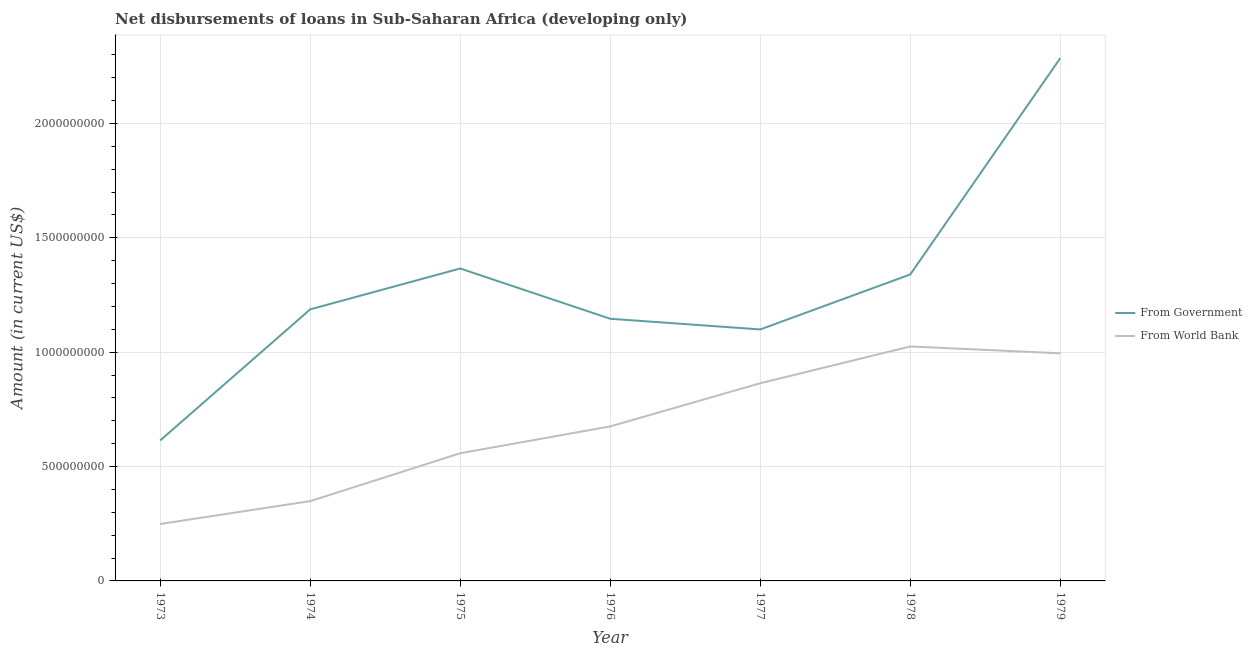Does the line corresponding to net disbursements of loan from government intersect with the line corresponding to net disbursements of loan from world bank?
Give a very brief answer. No. Is the number of lines equal to the number of legend labels?
Provide a succinct answer. Yes. What is the net disbursements of loan from world bank in 1979?
Keep it short and to the point. 9.95e+08. Across all years, what is the maximum net disbursements of loan from world bank?
Your response must be concise. 1.02e+09. Across all years, what is the minimum net disbursements of loan from world bank?
Provide a succinct answer. 2.49e+08. In which year was the net disbursements of loan from world bank maximum?
Offer a terse response. 1978. In which year was the net disbursements of loan from world bank minimum?
Your answer should be very brief. 1973. What is the total net disbursements of loan from world bank in the graph?
Offer a terse response. 4.72e+09. What is the difference between the net disbursements of loan from world bank in 1974 and that in 1978?
Provide a short and direct response. -6.76e+08. What is the difference between the net disbursements of loan from world bank in 1977 and the net disbursements of loan from government in 1973?
Offer a very short reply. 2.50e+08. What is the average net disbursements of loan from world bank per year?
Make the answer very short. 6.74e+08. In the year 1979, what is the difference between the net disbursements of loan from government and net disbursements of loan from world bank?
Offer a terse response. 1.29e+09. What is the ratio of the net disbursements of loan from government in 1975 to that in 1978?
Your answer should be very brief. 1.02. Is the net disbursements of loan from world bank in 1975 less than that in 1977?
Provide a short and direct response. Yes. Is the difference between the net disbursements of loan from government in 1973 and 1975 greater than the difference between the net disbursements of loan from world bank in 1973 and 1975?
Make the answer very short. No. What is the difference between the highest and the second highest net disbursements of loan from world bank?
Ensure brevity in your answer.  3.00e+07. What is the difference between the highest and the lowest net disbursements of loan from world bank?
Make the answer very short. 7.76e+08. Is the net disbursements of loan from world bank strictly greater than the net disbursements of loan from government over the years?
Give a very brief answer. No. Is the net disbursements of loan from world bank strictly less than the net disbursements of loan from government over the years?
Your answer should be compact. Yes. How many lines are there?
Your response must be concise. 2. How many years are there in the graph?
Provide a succinct answer. 7. What is the difference between two consecutive major ticks on the Y-axis?
Your answer should be compact. 5.00e+08. Where does the legend appear in the graph?
Offer a terse response. Center right. How many legend labels are there?
Your answer should be compact. 2. How are the legend labels stacked?
Provide a succinct answer. Vertical. What is the title of the graph?
Give a very brief answer. Net disbursements of loans in Sub-Saharan Africa (developing only). Does "Foreign liabilities" appear as one of the legend labels in the graph?
Provide a short and direct response. No. What is the Amount (in current US$) in From Government in 1973?
Offer a very short reply. 6.14e+08. What is the Amount (in current US$) of From World Bank in 1973?
Your answer should be compact. 2.49e+08. What is the Amount (in current US$) of From Government in 1974?
Provide a short and direct response. 1.19e+09. What is the Amount (in current US$) in From World Bank in 1974?
Your response must be concise. 3.49e+08. What is the Amount (in current US$) of From Government in 1975?
Your answer should be very brief. 1.37e+09. What is the Amount (in current US$) in From World Bank in 1975?
Your response must be concise. 5.58e+08. What is the Amount (in current US$) in From Government in 1976?
Provide a short and direct response. 1.15e+09. What is the Amount (in current US$) of From World Bank in 1976?
Keep it short and to the point. 6.75e+08. What is the Amount (in current US$) in From Government in 1977?
Ensure brevity in your answer.  1.10e+09. What is the Amount (in current US$) of From World Bank in 1977?
Make the answer very short. 8.64e+08. What is the Amount (in current US$) in From Government in 1978?
Offer a terse response. 1.34e+09. What is the Amount (in current US$) in From World Bank in 1978?
Make the answer very short. 1.02e+09. What is the Amount (in current US$) of From Government in 1979?
Give a very brief answer. 2.29e+09. What is the Amount (in current US$) in From World Bank in 1979?
Make the answer very short. 9.95e+08. Across all years, what is the maximum Amount (in current US$) in From Government?
Offer a terse response. 2.29e+09. Across all years, what is the maximum Amount (in current US$) of From World Bank?
Give a very brief answer. 1.02e+09. Across all years, what is the minimum Amount (in current US$) of From Government?
Give a very brief answer. 6.14e+08. Across all years, what is the minimum Amount (in current US$) in From World Bank?
Keep it short and to the point. 2.49e+08. What is the total Amount (in current US$) in From Government in the graph?
Offer a terse response. 9.04e+09. What is the total Amount (in current US$) of From World Bank in the graph?
Your answer should be very brief. 4.72e+09. What is the difference between the Amount (in current US$) of From Government in 1973 and that in 1974?
Your response must be concise. -5.73e+08. What is the difference between the Amount (in current US$) of From World Bank in 1973 and that in 1974?
Offer a terse response. -1.00e+08. What is the difference between the Amount (in current US$) of From Government in 1973 and that in 1975?
Provide a succinct answer. -7.52e+08. What is the difference between the Amount (in current US$) of From World Bank in 1973 and that in 1975?
Offer a terse response. -3.09e+08. What is the difference between the Amount (in current US$) in From Government in 1973 and that in 1976?
Keep it short and to the point. -5.32e+08. What is the difference between the Amount (in current US$) in From World Bank in 1973 and that in 1976?
Provide a short and direct response. -4.27e+08. What is the difference between the Amount (in current US$) in From Government in 1973 and that in 1977?
Offer a very short reply. -4.85e+08. What is the difference between the Amount (in current US$) in From World Bank in 1973 and that in 1977?
Provide a succinct answer. -6.15e+08. What is the difference between the Amount (in current US$) in From Government in 1973 and that in 1978?
Make the answer very short. -7.26e+08. What is the difference between the Amount (in current US$) in From World Bank in 1973 and that in 1978?
Your answer should be very brief. -7.76e+08. What is the difference between the Amount (in current US$) of From Government in 1973 and that in 1979?
Provide a succinct answer. -1.67e+09. What is the difference between the Amount (in current US$) in From World Bank in 1973 and that in 1979?
Your answer should be compact. -7.46e+08. What is the difference between the Amount (in current US$) of From Government in 1974 and that in 1975?
Your answer should be very brief. -1.79e+08. What is the difference between the Amount (in current US$) of From World Bank in 1974 and that in 1975?
Keep it short and to the point. -2.09e+08. What is the difference between the Amount (in current US$) of From Government in 1974 and that in 1976?
Give a very brief answer. 4.11e+07. What is the difference between the Amount (in current US$) in From World Bank in 1974 and that in 1976?
Provide a succinct answer. -3.27e+08. What is the difference between the Amount (in current US$) of From Government in 1974 and that in 1977?
Offer a very short reply. 8.77e+07. What is the difference between the Amount (in current US$) in From World Bank in 1974 and that in 1977?
Provide a succinct answer. -5.15e+08. What is the difference between the Amount (in current US$) in From Government in 1974 and that in 1978?
Provide a succinct answer. -1.53e+08. What is the difference between the Amount (in current US$) of From World Bank in 1974 and that in 1978?
Provide a short and direct response. -6.76e+08. What is the difference between the Amount (in current US$) in From Government in 1974 and that in 1979?
Give a very brief answer. -1.10e+09. What is the difference between the Amount (in current US$) in From World Bank in 1974 and that in 1979?
Offer a terse response. -6.46e+08. What is the difference between the Amount (in current US$) in From Government in 1975 and that in 1976?
Make the answer very short. 2.20e+08. What is the difference between the Amount (in current US$) in From World Bank in 1975 and that in 1976?
Your answer should be compact. -1.17e+08. What is the difference between the Amount (in current US$) in From Government in 1975 and that in 1977?
Offer a terse response. 2.66e+08. What is the difference between the Amount (in current US$) in From World Bank in 1975 and that in 1977?
Keep it short and to the point. -3.06e+08. What is the difference between the Amount (in current US$) of From Government in 1975 and that in 1978?
Provide a succinct answer. 2.61e+07. What is the difference between the Amount (in current US$) of From World Bank in 1975 and that in 1978?
Offer a very short reply. -4.67e+08. What is the difference between the Amount (in current US$) of From Government in 1975 and that in 1979?
Offer a terse response. -9.19e+08. What is the difference between the Amount (in current US$) in From World Bank in 1975 and that in 1979?
Keep it short and to the point. -4.37e+08. What is the difference between the Amount (in current US$) of From Government in 1976 and that in 1977?
Ensure brevity in your answer.  4.66e+07. What is the difference between the Amount (in current US$) of From World Bank in 1976 and that in 1977?
Make the answer very short. -1.89e+08. What is the difference between the Amount (in current US$) in From Government in 1976 and that in 1978?
Ensure brevity in your answer.  -1.94e+08. What is the difference between the Amount (in current US$) of From World Bank in 1976 and that in 1978?
Your response must be concise. -3.50e+08. What is the difference between the Amount (in current US$) of From Government in 1976 and that in 1979?
Provide a succinct answer. -1.14e+09. What is the difference between the Amount (in current US$) in From World Bank in 1976 and that in 1979?
Give a very brief answer. -3.20e+08. What is the difference between the Amount (in current US$) in From Government in 1977 and that in 1978?
Your answer should be very brief. -2.40e+08. What is the difference between the Amount (in current US$) in From World Bank in 1977 and that in 1978?
Keep it short and to the point. -1.61e+08. What is the difference between the Amount (in current US$) in From Government in 1977 and that in 1979?
Your answer should be very brief. -1.19e+09. What is the difference between the Amount (in current US$) of From World Bank in 1977 and that in 1979?
Give a very brief answer. -1.31e+08. What is the difference between the Amount (in current US$) in From Government in 1978 and that in 1979?
Ensure brevity in your answer.  -9.45e+08. What is the difference between the Amount (in current US$) in From World Bank in 1978 and that in 1979?
Offer a very short reply. 3.00e+07. What is the difference between the Amount (in current US$) of From Government in 1973 and the Amount (in current US$) of From World Bank in 1974?
Make the answer very short. 2.65e+08. What is the difference between the Amount (in current US$) of From Government in 1973 and the Amount (in current US$) of From World Bank in 1975?
Provide a short and direct response. 5.61e+07. What is the difference between the Amount (in current US$) of From Government in 1973 and the Amount (in current US$) of From World Bank in 1976?
Keep it short and to the point. -6.13e+07. What is the difference between the Amount (in current US$) in From Government in 1973 and the Amount (in current US$) in From World Bank in 1977?
Ensure brevity in your answer.  -2.50e+08. What is the difference between the Amount (in current US$) of From Government in 1973 and the Amount (in current US$) of From World Bank in 1978?
Your answer should be compact. -4.11e+08. What is the difference between the Amount (in current US$) in From Government in 1973 and the Amount (in current US$) in From World Bank in 1979?
Your answer should be very brief. -3.81e+08. What is the difference between the Amount (in current US$) in From Government in 1974 and the Amount (in current US$) in From World Bank in 1975?
Your answer should be very brief. 6.29e+08. What is the difference between the Amount (in current US$) in From Government in 1974 and the Amount (in current US$) in From World Bank in 1976?
Provide a succinct answer. 5.12e+08. What is the difference between the Amount (in current US$) in From Government in 1974 and the Amount (in current US$) in From World Bank in 1977?
Offer a terse response. 3.23e+08. What is the difference between the Amount (in current US$) in From Government in 1974 and the Amount (in current US$) in From World Bank in 1978?
Ensure brevity in your answer.  1.62e+08. What is the difference between the Amount (in current US$) of From Government in 1974 and the Amount (in current US$) of From World Bank in 1979?
Give a very brief answer. 1.92e+08. What is the difference between the Amount (in current US$) of From Government in 1975 and the Amount (in current US$) of From World Bank in 1976?
Provide a short and direct response. 6.90e+08. What is the difference between the Amount (in current US$) in From Government in 1975 and the Amount (in current US$) in From World Bank in 1977?
Provide a short and direct response. 5.02e+08. What is the difference between the Amount (in current US$) of From Government in 1975 and the Amount (in current US$) of From World Bank in 1978?
Your answer should be very brief. 3.41e+08. What is the difference between the Amount (in current US$) in From Government in 1975 and the Amount (in current US$) in From World Bank in 1979?
Provide a succinct answer. 3.71e+08. What is the difference between the Amount (in current US$) in From Government in 1976 and the Amount (in current US$) in From World Bank in 1977?
Offer a very short reply. 2.82e+08. What is the difference between the Amount (in current US$) of From Government in 1976 and the Amount (in current US$) of From World Bank in 1978?
Make the answer very short. 1.21e+08. What is the difference between the Amount (in current US$) in From Government in 1976 and the Amount (in current US$) in From World Bank in 1979?
Offer a very short reply. 1.51e+08. What is the difference between the Amount (in current US$) of From Government in 1977 and the Amount (in current US$) of From World Bank in 1978?
Make the answer very short. 7.44e+07. What is the difference between the Amount (in current US$) of From Government in 1977 and the Amount (in current US$) of From World Bank in 1979?
Ensure brevity in your answer.  1.04e+08. What is the difference between the Amount (in current US$) in From Government in 1978 and the Amount (in current US$) in From World Bank in 1979?
Your answer should be compact. 3.45e+08. What is the average Amount (in current US$) of From Government per year?
Offer a very short reply. 1.29e+09. What is the average Amount (in current US$) of From World Bank per year?
Your response must be concise. 6.74e+08. In the year 1973, what is the difference between the Amount (in current US$) in From Government and Amount (in current US$) in From World Bank?
Offer a terse response. 3.65e+08. In the year 1974, what is the difference between the Amount (in current US$) of From Government and Amount (in current US$) of From World Bank?
Keep it short and to the point. 8.38e+08. In the year 1975, what is the difference between the Amount (in current US$) in From Government and Amount (in current US$) in From World Bank?
Offer a very short reply. 8.08e+08. In the year 1976, what is the difference between the Amount (in current US$) in From Government and Amount (in current US$) in From World Bank?
Make the answer very short. 4.71e+08. In the year 1977, what is the difference between the Amount (in current US$) of From Government and Amount (in current US$) of From World Bank?
Give a very brief answer. 2.35e+08. In the year 1978, what is the difference between the Amount (in current US$) in From Government and Amount (in current US$) in From World Bank?
Keep it short and to the point. 3.15e+08. In the year 1979, what is the difference between the Amount (in current US$) of From Government and Amount (in current US$) of From World Bank?
Offer a terse response. 1.29e+09. What is the ratio of the Amount (in current US$) of From Government in 1973 to that in 1974?
Provide a short and direct response. 0.52. What is the ratio of the Amount (in current US$) of From World Bank in 1973 to that in 1974?
Give a very brief answer. 0.71. What is the ratio of the Amount (in current US$) of From Government in 1973 to that in 1975?
Offer a terse response. 0.45. What is the ratio of the Amount (in current US$) of From World Bank in 1973 to that in 1975?
Provide a short and direct response. 0.45. What is the ratio of the Amount (in current US$) in From Government in 1973 to that in 1976?
Ensure brevity in your answer.  0.54. What is the ratio of the Amount (in current US$) in From World Bank in 1973 to that in 1976?
Provide a short and direct response. 0.37. What is the ratio of the Amount (in current US$) in From Government in 1973 to that in 1977?
Offer a very short reply. 0.56. What is the ratio of the Amount (in current US$) in From World Bank in 1973 to that in 1977?
Your answer should be compact. 0.29. What is the ratio of the Amount (in current US$) in From Government in 1973 to that in 1978?
Provide a short and direct response. 0.46. What is the ratio of the Amount (in current US$) of From World Bank in 1973 to that in 1978?
Provide a succinct answer. 0.24. What is the ratio of the Amount (in current US$) of From Government in 1973 to that in 1979?
Offer a terse response. 0.27. What is the ratio of the Amount (in current US$) of From World Bank in 1973 to that in 1979?
Your answer should be compact. 0.25. What is the ratio of the Amount (in current US$) of From Government in 1974 to that in 1975?
Make the answer very short. 0.87. What is the ratio of the Amount (in current US$) of From World Bank in 1974 to that in 1975?
Provide a succinct answer. 0.63. What is the ratio of the Amount (in current US$) in From Government in 1974 to that in 1976?
Ensure brevity in your answer.  1.04. What is the ratio of the Amount (in current US$) of From World Bank in 1974 to that in 1976?
Provide a short and direct response. 0.52. What is the ratio of the Amount (in current US$) of From Government in 1974 to that in 1977?
Make the answer very short. 1.08. What is the ratio of the Amount (in current US$) in From World Bank in 1974 to that in 1977?
Your response must be concise. 0.4. What is the ratio of the Amount (in current US$) in From Government in 1974 to that in 1978?
Your response must be concise. 0.89. What is the ratio of the Amount (in current US$) of From World Bank in 1974 to that in 1978?
Provide a short and direct response. 0.34. What is the ratio of the Amount (in current US$) in From Government in 1974 to that in 1979?
Offer a very short reply. 0.52. What is the ratio of the Amount (in current US$) of From World Bank in 1974 to that in 1979?
Provide a short and direct response. 0.35. What is the ratio of the Amount (in current US$) of From Government in 1975 to that in 1976?
Provide a succinct answer. 1.19. What is the ratio of the Amount (in current US$) in From World Bank in 1975 to that in 1976?
Give a very brief answer. 0.83. What is the ratio of the Amount (in current US$) in From Government in 1975 to that in 1977?
Ensure brevity in your answer.  1.24. What is the ratio of the Amount (in current US$) in From World Bank in 1975 to that in 1977?
Offer a terse response. 0.65. What is the ratio of the Amount (in current US$) in From Government in 1975 to that in 1978?
Provide a short and direct response. 1.02. What is the ratio of the Amount (in current US$) of From World Bank in 1975 to that in 1978?
Give a very brief answer. 0.54. What is the ratio of the Amount (in current US$) of From Government in 1975 to that in 1979?
Keep it short and to the point. 0.6. What is the ratio of the Amount (in current US$) of From World Bank in 1975 to that in 1979?
Your answer should be very brief. 0.56. What is the ratio of the Amount (in current US$) of From Government in 1976 to that in 1977?
Provide a succinct answer. 1.04. What is the ratio of the Amount (in current US$) of From World Bank in 1976 to that in 1977?
Your answer should be very brief. 0.78. What is the ratio of the Amount (in current US$) of From Government in 1976 to that in 1978?
Offer a terse response. 0.86. What is the ratio of the Amount (in current US$) in From World Bank in 1976 to that in 1978?
Provide a short and direct response. 0.66. What is the ratio of the Amount (in current US$) of From Government in 1976 to that in 1979?
Offer a terse response. 0.5. What is the ratio of the Amount (in current US$) of From World Bank in 1976 to that in 1979?
Provide a short and direct response. 0.68. What is the ratio of the Amount (in current US$) of From Government in 1977 to that in 1978?
Provide a short and direct response. 0.82. What is the ratio of the Amount (in current US$) of From World Bank in 1977 to that in 1978?
Your response must be concise. 0.84. What is the ratio of the Amount (in current US$) in From Government in 1977 to that in 1979?
Make the answer very short. 0.48. What is the ratio of the Amount (in current US$) in From World Bank in 1977 to that in 1979?
Make the answer very short. 0.87. What is the ratio of the Amount (in current US$) of From Government in 1978 to that in 1979?
Your response must be concise. 0.59. What is the ratio of the Amount (in current US$) of From World Bank in 1978 to that in 1979?
Offer a very short reply. 1.03. What is the difference between the highest and the second highest Amount (in current US$) in From Government?
Make the answer very short. 9.19e+08. What is the difference between the highest and the second highest Amount (in current US$) in From World Bank?
Provide a short and direct response. 3.00e+07. What is the difference between the highest and the lowest Amount (in current US$) in From Government?
Provide a short and direct response. 1.67e+09. What is the difference between the highest and the lowest Amount (in current US$) in From World Bank?
Provide a short and direct response. 7.76e+08. 